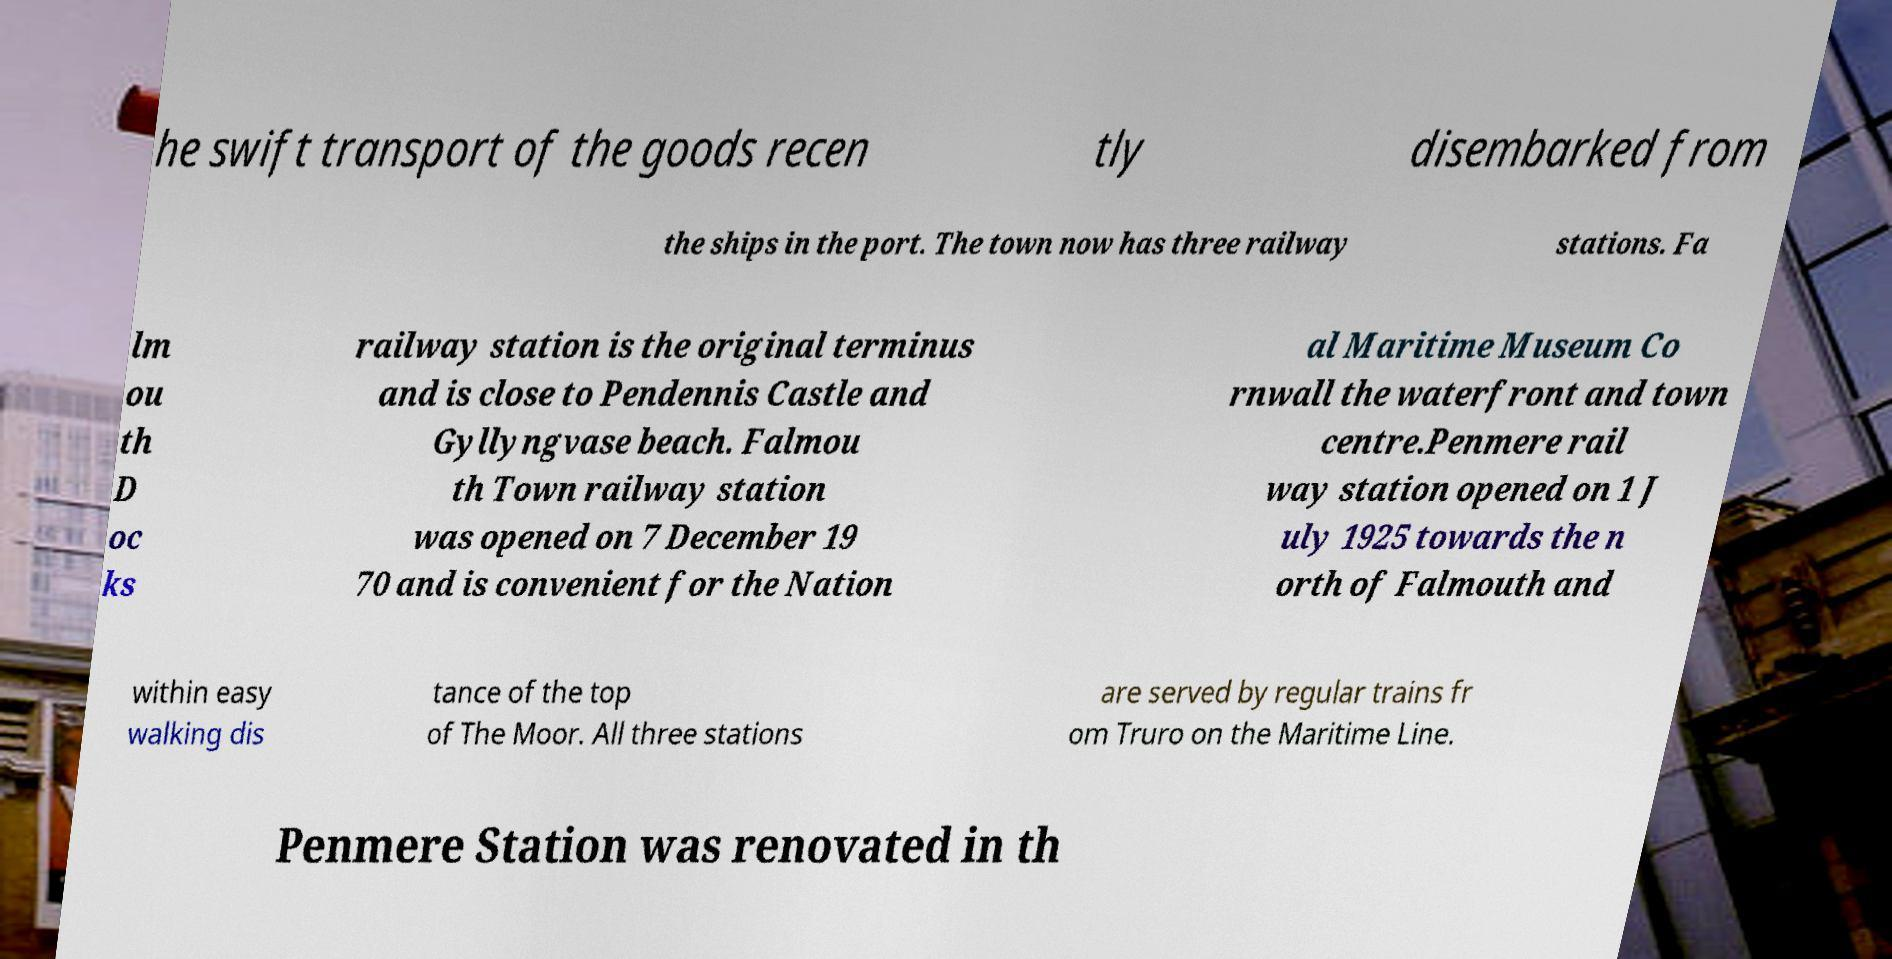Please read and relay the text visible in this image. What does it say? he swift transport of the goods recen tly disembarked from the ships in the port. The town now has three railway stations. Fa lm ou th D oc ks railway station is the original terminus and is close to Pendennis Castle and Gyllyngvase beach. Falmou th Town railway station was opened on 7 December 19 70 and is convenient for the Nation al Maritime Museum Co rnwall the waterfront and town centre.Penmere rail way station opened on 1 J uly 1925 towards the n orth of Falmouth and within easy walking dis tance of the top of The Moor. All three stations are served by regular trains fr om Truro on the Maritime Line. Penmere Station was renovated in th 